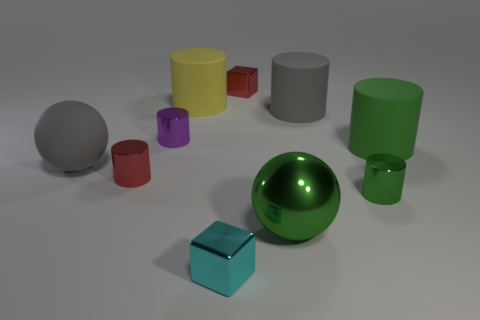Subtract all red cylinders. How many cylinders are left? 5 Subtract all large gray cylinders. How many cylinders are left? 5 Subtract all yellow balls. Subtract all cyan cylinders. How many balls are left? 2 Subtract all cubes. How many objects are left? 8 Subtract all big metallic balls. Subtract all green things. How many objects are left? 6 Add 5 big spheres. How many big spheres are left? 7 Add 9 small gray metallic things. How many small gray metallic things exist? 9 Subtract 0 gray cubes. How many objects are left? 10 